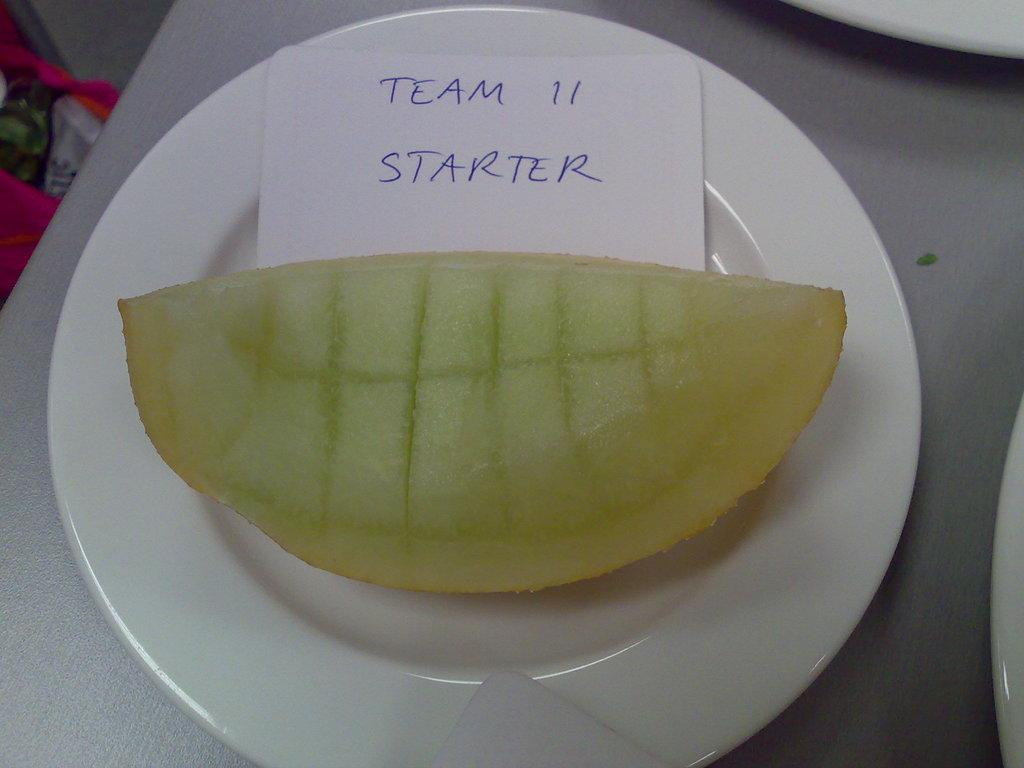What type of food item is present in the image? There is a fruit piece in the image. What other object can be seen in the image besides the fruit piece? There is a paper in the image. What can be seen on the table in the image? There are white plates on the table in the image. Where are the bags located in the image? The bags are visible in the top left corner of the image. What type of writing can be seen on the fruit piece in the image? There is no writing present on the fruit piece in the image. 